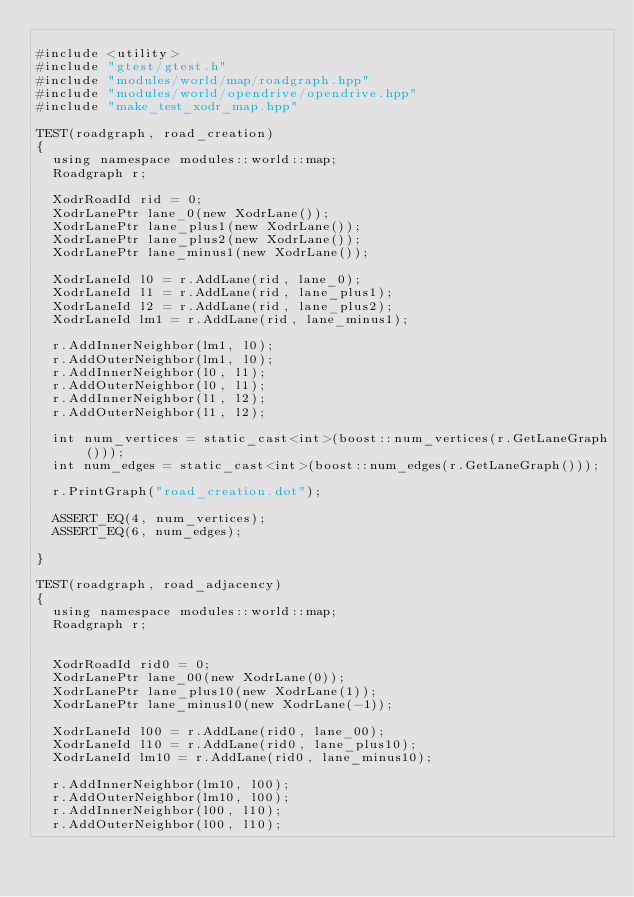<code> <loc_0><loc_0><loc_500><loc_500><_C++_>
#include <utility>
#include "gtest/gtest.h"
#include "modules/world/map/roadgraph.hpp"
#include "modules/world/opendrive/opendrive.hpp"
#include "make_test_xodr_map.hpp"

TEST(roadgraph, road_creation)
{
  using namespace modules::world::map;
  Roadgraph r;
  
  XodrRoadId rid = 0;
  XodrLanePtr lane_0(new XodrLane());
  XodrLanePtr lane_plus1(new XodrLane());
  XodrLanePtr lane_plus2(new XodrLane());
  XodrLanePtr lane_minus1(new XodrLane());

  XodrLaneId l0 = r.AddLane(rid, lane_0);
  XodrLaneId l1 = r.AddLane(rid, lane_plus1);
  XodrLaneId l2 = r.AddLane(rid, lane_plus2);
  XodrLaneId lm1 = r.AddLane(rid, lane_minus1);

  r.AddInnerNeighbor(lm1, l0);
  r.AddOuterNeighbor(lm1, l0);
  r.AddInnerNeighbor(l0, l1);
  r.AddOuterNeighbor(l0, l1);
  r.AddInnerNeighbor(l1, l2);
  r.AddOuterNeighbor(l1, l2);

  int num_vertices = static_cast<int>(boost::num_vertices(r.GetLaneGraph()));
  int num_edges = static_cast<int>(boost::num_edges(r.GetLaneGraph()));

  r.PrintGraph("road_creation.dot");

  ASSERT_EQ(4, num_vertices);
  ASSERT_EQ(6, num_edges);

}

TEST(roadgraph, road_adjacency)
{
  using namespace modules::world::map;
  Roadgraph r;


  XodrRoadId rid0 = 0;
  XodrLanePtr lane_00(new XodrLane(0));
  XodrLanePtr lane_plus10(new XodrLane(1));
  XodrLanePtr lane_minus10(new XodrLane(-1));

  XodrLaneId l00 = r.AddLane(rid0, lane_00);
  XodrLaneId l10 = r.AddLane(rid0, lane_plus10);
  XodrLaneId lm10 = r.AddLane(rid0, lane_minus10);

  r.AddInnerNeighbor(lm10, l00);
  r.AddOuterNeighbor(lm10, l00);
  r.AddInnerNeighbor(l00, l10);
  r.AddOuterNeighbor(l00, l10);
</code> 